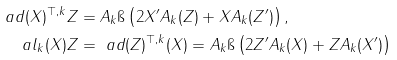Convert formula to latex. <formula><loc_0><loc_0><loc_500><loc_500>\ a d ( X ) ^ { \top , k } Z & = A _ { k } \i \left ( 2 X ^ { \prime } A _ { k } ( Z ) + X A _ { k } ( Z ^ { \prime } ) \right ) , \\ \ a l _ { k } ( X ) Z & = \ a d ( Z ) ^ { \top , k } ( X ) = A _ { k } \i \left ( 2 Z ^ { \prime } A _ { k } ( X ) + Z A _ { k } ( X ^ { \prime } ) \right )</formula> 